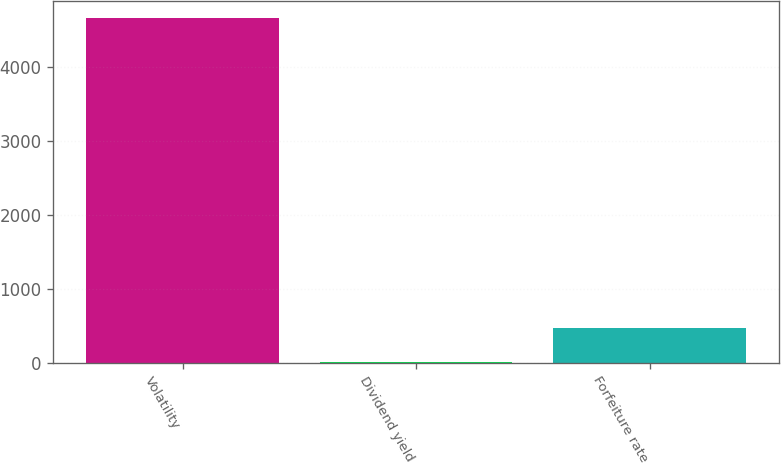Convert chart to OTSL. <chart><loc_0><loc_0><loc_500><loc_500><bar_chart><fcel>Volatility<fcel>Dividend yield<fcel>Forfeiture rate<nl><fcel>4656<fcel>3.4<fcel>468.66<nl></chart> 